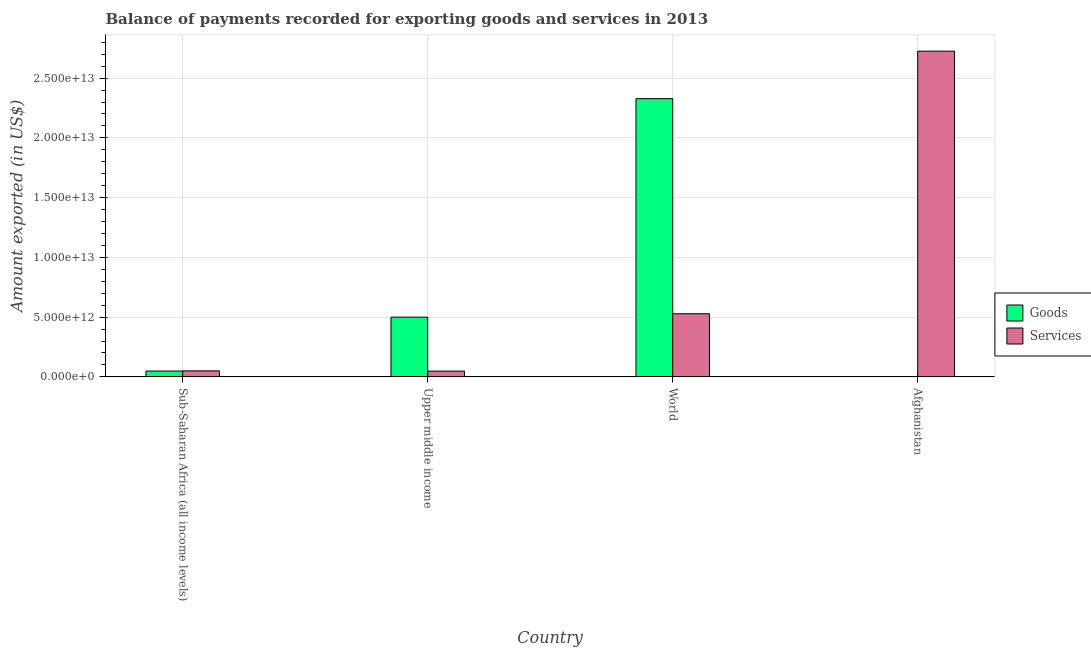Are the number of bars per tick equal to the number of legend labels?
Keep it short and to the point. Yes. How many bars are there on the 3rd tick from the left?
Provide a short and direct response. 2. What is the amount of services exported in Upper middle income?
Provide a succinct answer. 4.83e+11. Across all countries, what is the maximum amount of goods exported?
Your answer should be very brief. 2.33e+13. Across all countries, what is the minimum amount of services exported?
Provide a succinct answer. 4.83e+11. In which country was the amount of goods exported maximum?
Provide a succinct answer. World. In which country was the amount of goods exported minimum?
Provide a succinct answer. Afghanistan. What is the total amount of goods exported in the graph?
Offer a very short reply. 2.88e+13. What is the difference between the amount of goods exported in Afghanistan and that in Upper middle income?
Provide a short and direct response. -4.99e+12. What is the difference between the amount of goods exported in Upper middle income and the amount of services exported in World?
Make the answer very short. -2.83e+11. What is the average amount of services exported per country?
Your response must be concise. 8.38e+12. What is the difference between the amount of services exported and amount of goods exported in World?
Make the answer very short. -1.80e+13. In how many countries, is the amount of goods exported greater than 23000000000000 US$?
Offer a terse response. 1. What is the ratio of the amount of services exported in Afghanistan to that in Sub-Saharan Africa (all income levels)?
Offer a terse response. 54.23. Is the amount of services exported in Afghanistan less than that in Upper middle income?
Provide a short and direct response. No. What is the difference between the highest and the second highest amount of services exported?
Make the answer very short. 2.20e+13. What is the difference between the highest and the lowest amount of goods exported?
Keep it short and to the point. 2.33e+13. What does the 2nd bar from the left in Upper middle income represents?
Ensure brevity in your answer.  Services. What does the 1st bar from the right in Afghanistan represents?
Your response must be concise. Services. How many bars are there?
Make the answer very short. 8. Are all the bars in the graph horizontal?
Ensure brevity in your answer.  No. How many countries are there in the graph?
Offer a terse response. 4. What is the difference between two consecutive major ticks on the Y-axis?
Make the answer very short. 5.00e+12. Does the graph contain any zero values?
Your response must be concise. No. Does the graph contain grids?
Your answer should be very brief. Yes. Where does the legend appear in the graph?
Your answer should be very brief. Center right. How are the legend labels stacked?
Give a very brief answer. Vertical. What is the title of the graph?
Give a very brief answer. Balance of payments recorded for exporting goods and services in 2013. What is the label or title of the X-axis?
Provide a short and direct response. Country. What is the label or title of the Y-axis?
Ensure brevity in your answer.  Amount exported (in US$). What is the Amount exported (in US$) in Goods in Sub-Saharan Africa (all income levels)?
Give a very brief answer. 4.87e+11. What is the Amount exported (in US$) of Services in Sub-Saharan Africa (all income levels)?
Ensure brevity in your answer.  5.03e+11. What is the Amount exported (in US$) of Goods in Upper middle income?
Provide a succinct answer. 5.00e+12. What is the Amount exported (in US$) in Services in Upper middle income?
Offer a terse response. 4.83e+11. What is the Amount exported (in US$) in Goods in World?
Your answer should be very brief. 2.33e+13. What is the Amount exported (in US$) of Services in World?
Provide a succinct answer. 5.28e+12. What is the Amount exported (in US$) of Goods in Afghanistan?
Your answer should be compact. 3.58e+09. What is the Amount exported (in US$) in Services in Afghanistan?
Your answer should be very brief. 2.73e+13. Across all countries, what is the maximum Amount exported (in US$) of Goods?
Offer a terse response. 2.33e+13. Across all countries, what is the maximum Amount exported (in US$) in Services?
Your response must be concise. 2.73e+13. Across all countries, what is the minimum Amount exported (in US$) of Goods?
Provide a succinct answer. 3.58e+09. Across all countries, what is the minimum Amount exported (in US$) of Services?
Your answer should be compact. 4.83e+11. What is the total Amount exported (in US$) in Goods in the graph?
Provide a short and direct response. 2.88e+13. What is the total Amount exported (in US$) in Services in the graph?
Provide a short and direct response. 3.35e+13. What is the difference between the Amount exported (in US$) in Goods in Sub-Saharan Africa (all income levels) and that in Upper middle income?
Offer a very short reply. -4.51e+12. What is the difference between the Amount exported (in US$) in Services in Sub-Saharan Africa (all income levels) and that in Upper middle income?
Provide a short and direct response. 1.94e+1. What is the difference between the Amount exported (in US$) of Goods in Sub-Saharan Africa (all income levels) and that in World?
Offer a terse response. -2.28e+13. What is the difference between the Amount exported (in US$) of Services in Sub-Saharan Africa (all income levels) and that in World?
Your answer should be compact. -4.78e+12. What is the difference between the Amount exported (in US$) in Goods in Sub-Saharan Africa (all income levels) and that in Afghanistan?
Make the answer very short. 4.84e+11. What is the difference between the Amount exported (in US$) in Services in Sub-Saharan Africa (all income levels) and that in Afghanistan?
Keep it short and to the point. -2.68e+13. What is the difference between the Amount exported (in US$) in Goods in Upper middle income and that in World?
Provide a short and direct response. -1.83e+13. What is the difference between the Amount exported (in US$) in Services in Upper middle income and that in World?
Give a very brief answer. -4.80e+12. What is the difference between the Amount exported (in US$) in Goods in Upper middle income and that in Afghanistan?
Make the answer very short. 4.99e+12. What is the difference between the Amount exported (in US$) of Services in Upper middle income and that in Afghanistan?
Provide a succinct answer. -2.68e+13. What is the difference between the Amount exported (in US$) of Goods in World and that in Afghanistan?
Your answer should be very brief. 2.33e+13. What is the difference between the Amount exported (in US$) in Services in World and that in Afghanistan?
Keep it short and to the point. -2.20e+13. What is the difference between the Amount exported (in US$) of Goods in Sub-Saharan Africa (all income levels) and the Amount exported (in US$) of Services in Upper middle income?
Make the answer very short. 3.95e+09. What is the difference between the Amount exported (in US$) of Goods in Sub-Saharan Africa (all income levels) and the Amount exported (in US$) of Services in World?
Provide a short and direct response. -4.79e+12. What is the difference between the Amount exported (in US$) of Goods in Sub-Saharan Africa (all income levels) and the Amount exported (in US$) of Services in Afghanistan?
Your response must be concise. -2.68e+13. What is the difference between the Amount exported (in US$) in Goods in Upper middle income and the Amount exported (in US$) in Services in World?
Ensure brevity in your answer.  -2.83e+11. What is the difference between the Amount exported (in US$) in Goods in Upper middle income and the Amount exported (in US$) in Services in Afghanistan?
Provide a succinct answer. -2.23e+13. What is the difference between the Amount exported (in US$) of Goods in World and the Amount exported (in US$) of Services in Afghanistan?
Keep it short and to the point. -3.97e+12. What is the average Amount exported (in US$) of Goods per country?
Make the answer very short. 7.19e+12. What is the average Amount exported (in US$) in Services per country?
Keep it short and to the point. 8.38e+12. What is the difference between the Amount exported (in US$) in Goods and Amount exported (in US$) in Services in Sub-Saharan Africa (all income levels)?
Make the answer very short. -1.54e+1. What is the difference between the Amount exported (in US$) of Goods and Amount exported (in US$) of Services in Upper middle income?
Keep it short and to the point. 4.51e+12. What is the difference between the Amount exported (in US$) of Goods and Amount exported (in US$) of Services in World?
Your response must be concise. 1.80e+13. What is the difference between the Amount exported (in US$) of Goods and Amount exported (in US$) of Services in Afghanistan?
Provide a short and direct response. -2.73e+13. What is the ratio of the Amount exported (in US$) in Goods in Sub-Saharan Africa (all income levels) to that in Upper middle income?
Your answer should be compact. 0.1. What is the ratio of the Amount exported (in US$) of Services in Sub-Saharan Africa (all income levels) to that in Upper middle income?
Your answer should be very brief. 1.04. What is the ratio of the Amount exported (in US$) in Goods in Sub-Saharan Africa (all income levels) to that in World?
Give a very brief answer. 0.02. What is the ratio of the Amount exported (in US$) in Services in Sub-Saharan Africa (all income levels) to that in World?
Make the answer very short. 0.1. What is the ratio of the Amount exported (in US$) in Goods in Sub-Saharan Africa (all income levels) to that in Afghanistan?
Offer a very short reply. 136.03. What is the ratio of the Amount exported (in US$) in Services in Sub-Saharan Africa (all income levels) to that in Afghanistan?
Ensure brevity in your answer.  0.02. What is the ratio of the Amount exported (in US$) of Goods in Upper middle income to that in World?
Your answer should be very brief. 0.21. What is the ratio of the Amount exported (in US$) of Services in Upper middle income to that in World?
Offer a terse response. 0.09. What is the ratio of the Amount exported (in US$) in Goods in Upper middle income to that in Afghanistan?
Your answer should be very brief. 1395.62. What is the ratio of the Amount exported (in US$) of Services in Upper middle income to that in Afghanistan?
Your answer should be compact. 0.02. What is the ratio of the Amount exported (in US$) in Goods in World to that in Afghanistan?
Your response must be concise. 6501.97. What is the ratio of the Amount exported (in US$) in Services in World to that in Afghanistan?
Provide a succinct answer. 0.19. What is the difference between the highest and the second highest Amount exported (in US$) in Goods?
Your response must be concise. 1.83e+13. What is the difference between the highest and the second highest Amount exported (in US$) in Services?
Provide a short and direct response. 2.20e+13. What is the difference between the highest and the lowest Amount exported (in US$) of Goods?
Give a very brief answer. 2.33e+13. What is the difference between the highest and the lowest Amount exported (in US$) of Services?
Provide a succinct answer. 2.68e+13. 